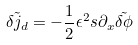Convert formula to latex. <formula><loc_0><loc_0><loc_500><loc_500>\tilde { \delta j _ { d } } = - \frac { 1 } { 2 } \epsilon ^ { 2 } s \partial _ { x } \tilde { \delta \phi }</formula> 